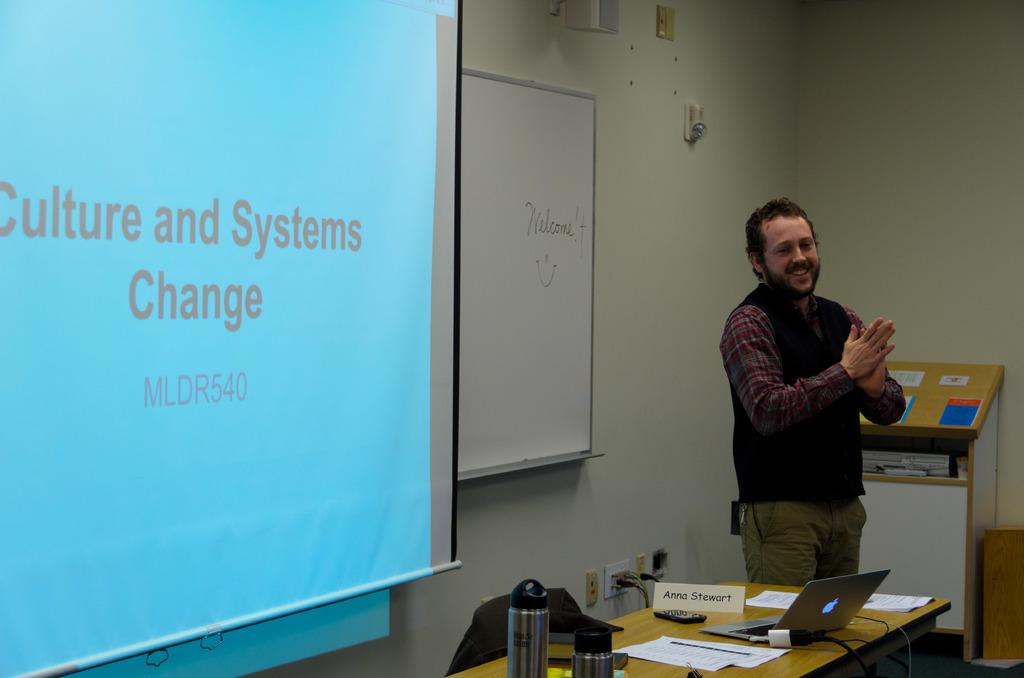<image>
Share a concise interpretation of the image provided. Person standing in front of a screen which says "Culture and Systems Change". 